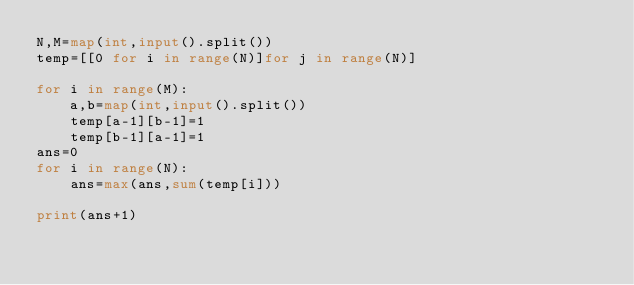Convert code to text. <code><loc_0><loc_0><loc_500><loc_500><_Python_>N,M=map(int,input().split())
temp=[[0 for i in range(N)]for j in range(N)]

for i in range(M):
    a,b=map(int,input().split())
    temp[a-1][b-1]=1
    temp[b-1][a-1]=1
ans=0
for i in range(N):
    ans=max(ans,sum(temp[i]))

print(ans+1)</code> 